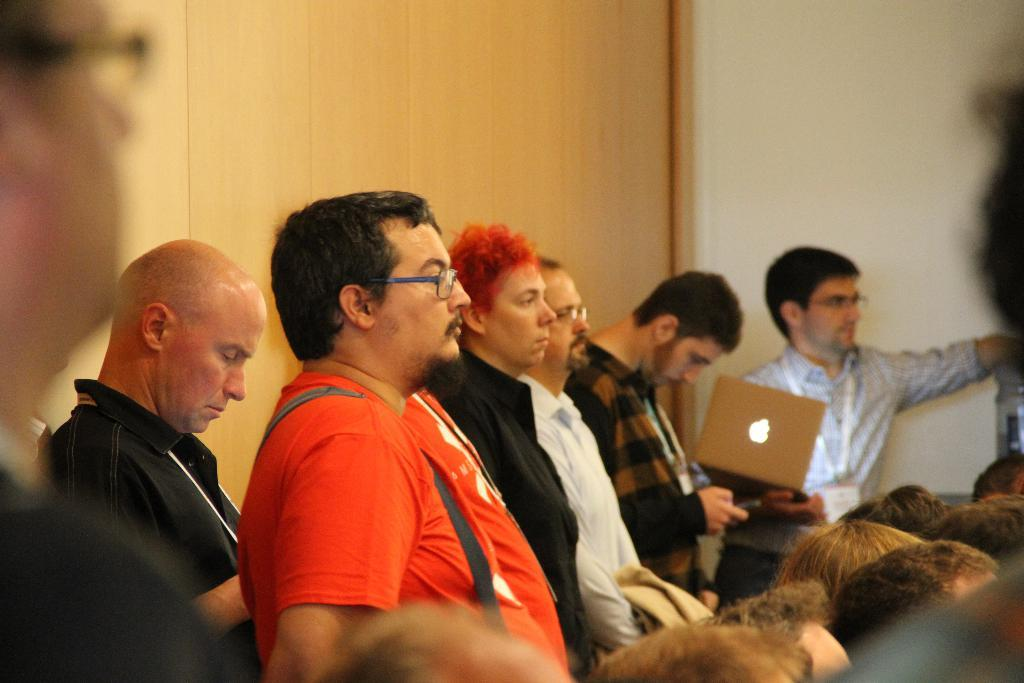What can be seen in the image? There is a group of people in the image. How are the people dressed? The people are wearing different color dresses. What object is one person holding? One person is holding a laptop. What is visible in the background of the image? There is a wall in the background of the image. What channel is the laptop tuned to in the image? The image does not provide information about the laptop's channel or any television-related activity. 